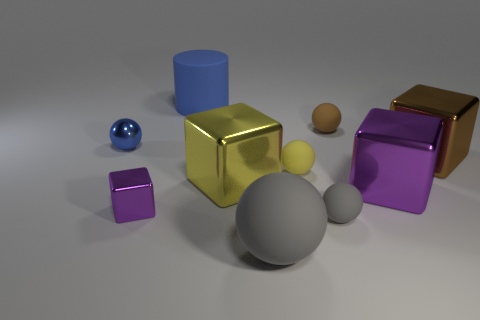What is the size of the shiny object that is the same color as the cylinder?
Ensure brevity in your answer.  Small. Does the small metal sphere have the same color as the rubber cylinder?
Make the answer very short. Yes. What number of things are either big green shiny objects or blue things?
Your answer should be very brief. 2. Does the large yellow metallic object have the same shape as the large purple object?
Give a very brief answer. Yes. There is a purple thing to the right of the small purple metallic thing; is it the same size as the purple block that is in front of the big purple object?
Provide a succinct answer. No. What is the material of the big thing that is both behind the small yellow rubber ball and in front of the large rubber cylinder?
Provide a short and direct response. Metal. Is the number of large yellow objects right of the small yellow matte ball less than the number of brown matte balls?
Provide a succinct answer. Yes. Are there more rubber cylinders than large purple rubber cylinders?
Your response must be concise. Yes. Are there any tiny brown balls that are on the right side of the matte thing to the left of the big thing in front of the small gray rubber object?
Keep it short and to the point. Yes. How many other objects are the same size as the brown metal object?
Ensure brevity in your answer.  4. 